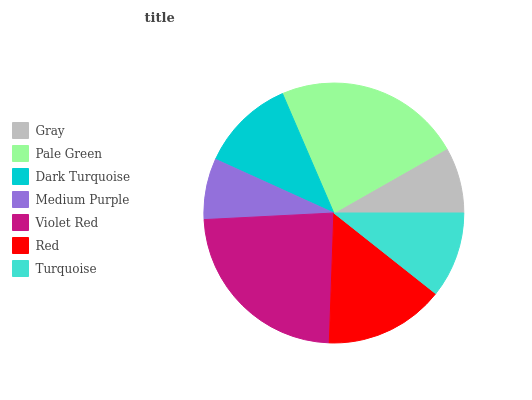Is Medium Purple the minimum?
Answer yes or no. Yes. Is Violet Red the maximum?
Answer yes or no. Yes. Is Pale Green the minimum?
Answer yes or no. No. Is Pale Green the maximum?
Answer yes or no. No. Is Pale Green greater than Gray?
Answer yes or no. Yes. Is Gray less than Pale Green?
Answer yes or no. Yes. Is Gray greater than Pale Green?
Answer yes or no. No. Is Pale Green less than Gray?
Answer yes or no. No. Is Dark Turquoise the high median?
Answer yes or no. Yes. Is Dark Turquoise the low median?
Answer yes or no. Yes. Is Gray the high median?
Answer yes or no. No. Is Violet Red the low median?
Answer yes or no. No. 